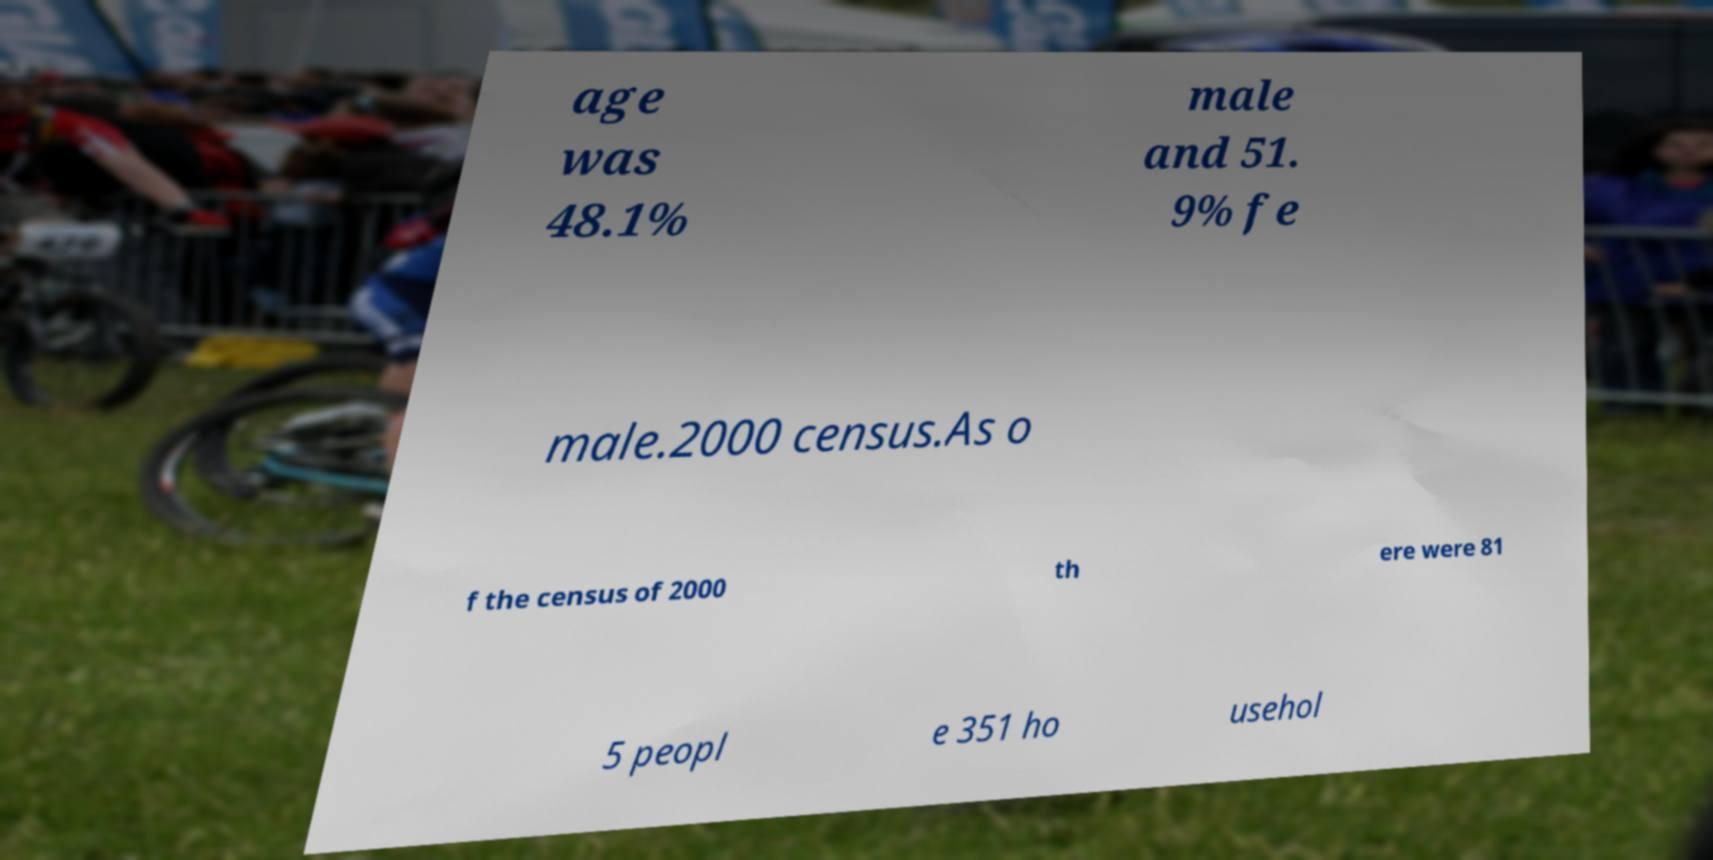There's text embedded in this image that I need extracted. Can you transcribe it verbatim? age was 48.1% male and 51. 9% fe male.2000 census.As o f the census of 2000 th ere were 81 5 peopl e 351 ho usehol 